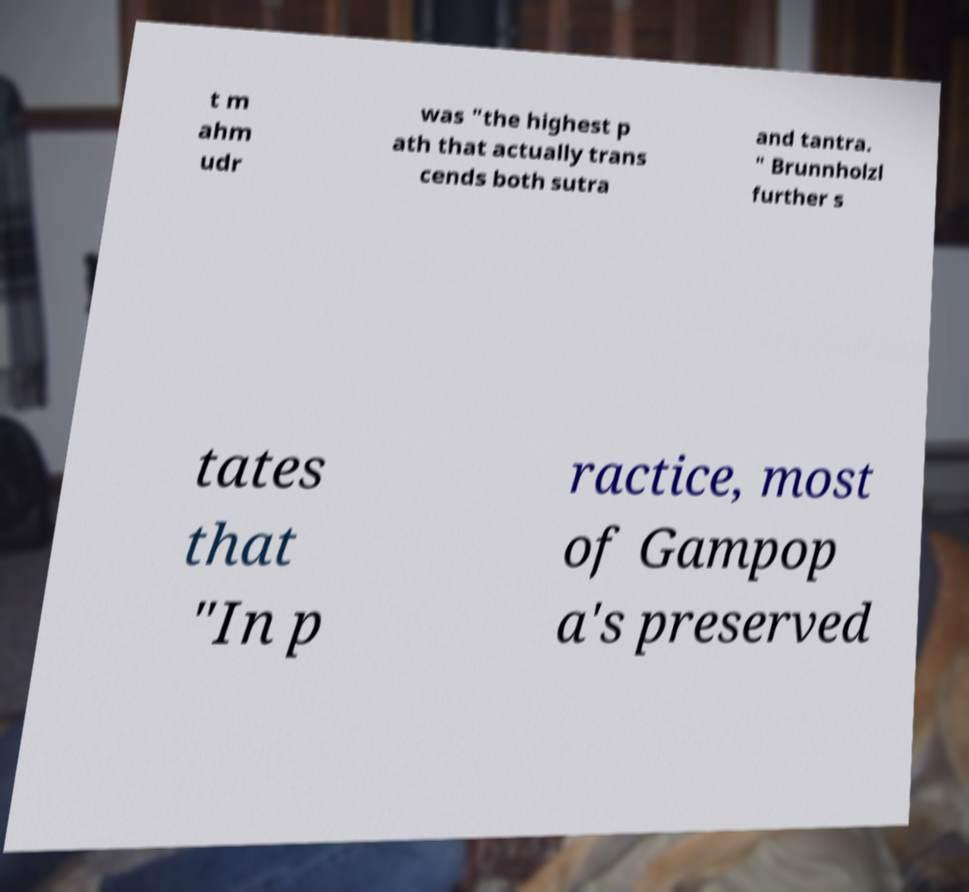Can you accurately transcribe the text from the provided image for me? t m ahm udr was "the highest p ath that actually trans cends both sutra and tantra. " Brunnholzl further s tates that "In p ractice, most of Gampop a's preserved 